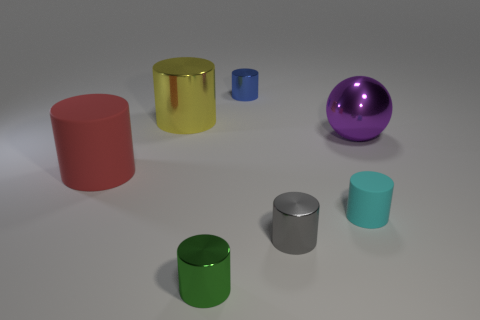Subtract all red matte cylinders. How many cylinders are left? 5 Subtract 1 cylinders. How many cylinders are left? 5 Subtract all red cylinders. How many cylinders are left? 5 Subtract all green cylinders. Subtract all purple blocks. How many cylinders are left? 5 Subtract all spheres. How many objects are left? 6 Add 1 blue shiny objects. How many objects exist? 8 Subtract all small green metal cylinders. Subtract all big matte cylinders. How many objects are left? 5 Add 1 large things. How many large things are left? 4 Add 1 cyan things. How many cyan things exist? 2 Subtract 0 yellow spheres. How many objects are left? 7 